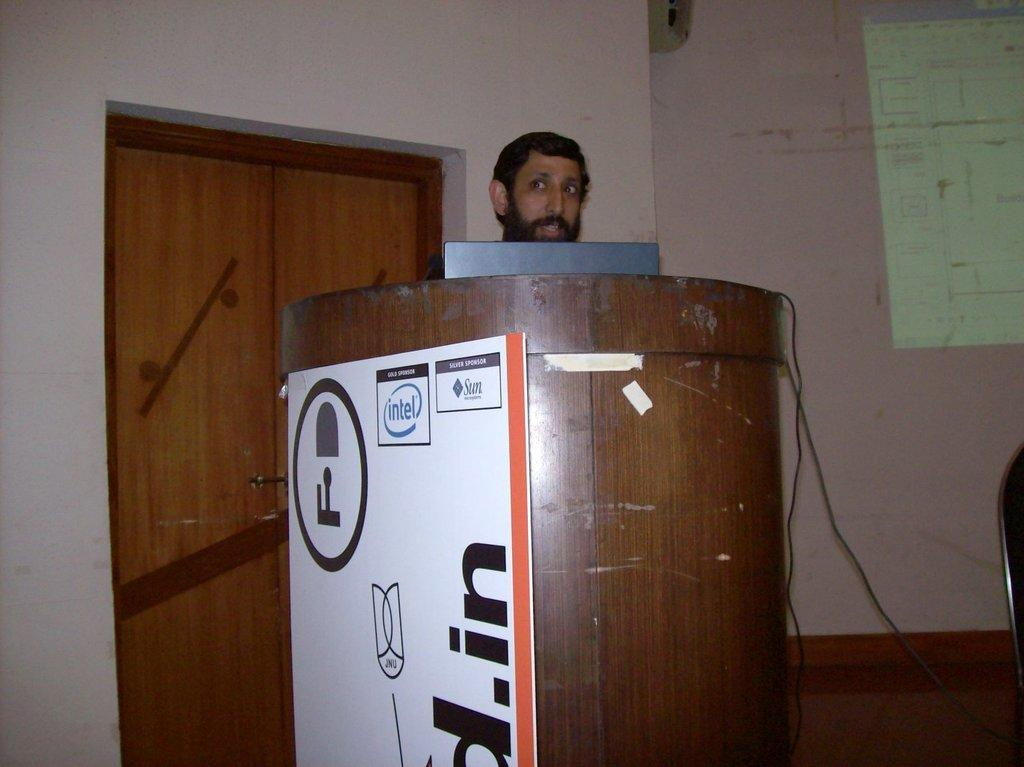<image>
Relay a brief, clear account of the picture shown. A man is giving a presentation at a podium, and on the side of the podium it reads that Intel and Sun are sponsors for this event. 